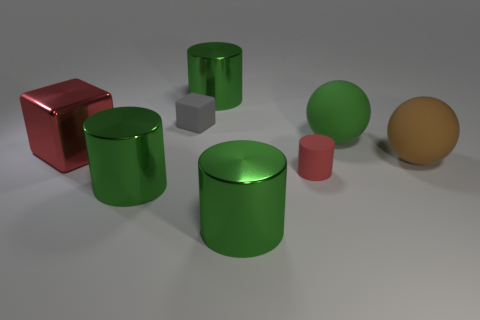What number of other things are the same color as the rubber cylinder?
Keep it short and to the point. 1. Do the small rubber cylinder and the cube that is in front of the green matte sphere have the same color?
Ensure brevity in your answer.  Yes. What is the color of the large metal thing that is the same shape as the tiny gray thing?
Give a very brief answer. Red. Are there any brown things that have the same shape as the green rubber object?
Keep it short and to the point. Yes. Is the color of the small cylinder the same as the big cube?
Give a very brief answer. Yes. There is a metal thing to the right of the green metal object that is behind the rubber block on the left side of the small red cylinder; how big is it?
Keep it short and to the point. Large. There is a sphere that is the same size as the brown object; what is it made of?
Your answer should be very brief. Rubber. Is there a matte cylinder that has the same size as the red rubber thing?
Give a very brief answer. No. Is the size of the block that is in front of the gray rubber block the same as the small gray rubber cube?
Provide a succinct answer. No. What is the shape of the rubber object that is both right of the small red rubber object and on the left side of the large brown thing?
Your response must be concise. Sphere. 